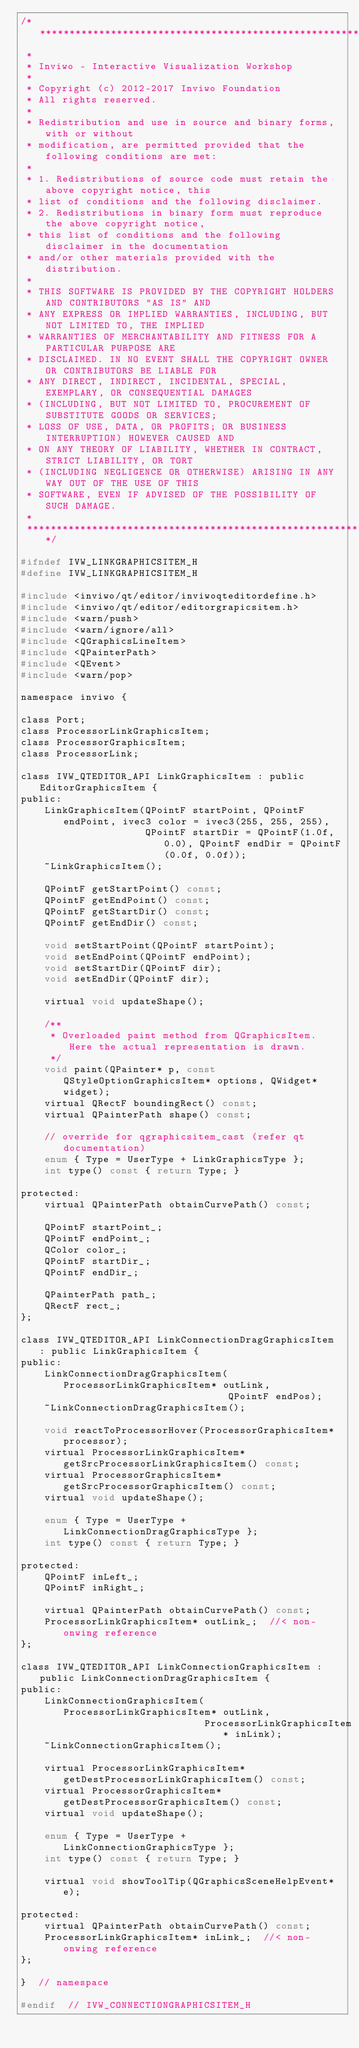<code> <loc_0><loc_0><loc_500><loc_500><_C_>/*********************************************************************************
 *
 * Inviwo - Interactive Visualization Workshop
 *
 * Copyright (c) 2012-2017 Inviwo Foundation
 * All rights reserved.
 *
 * Redistribution and use in source and binary forms, with or without
 * modification, are permitted provided that the following conditions are met:
 *
 * 1. Redistributions of source code must retain the above copyright notice, this
 * list of conditions and the following disclaimer.
 * 2. Redistributions in binary form must reproduce the above copyright notice,
 * this list of conditions and the following disclaimer in the documentation
 * and/or other materials provided with the distribution.
 *
 * THIS SOFTWARE IS PROVIDED BY THE COPYRIGHT HOLDERS AND CONTRIBUTORS "AS IS" AND
 * ANY EXPRESS OR IMPLIED WARRANTIES, INCLUDING, BUT NOT LIMITED TO, THE IMPLIED
 * WARRANTIES OF MERCHANTABILITY AND FITNESS FOR A PARTICULAR PURPOSE ARE
 * DISCLAIMED. IN NO EVENT SHALL THE COPYRIGHT OWNER OR CONTRIBUTORS BE LIABLE FOR
 * ANY DIRECT, INDIRECT, INCIDENTAL, SPECIAL, EXEMPLARY, OR CONSEQUENTIAL DAMAGES
 * (INCLUDING, BUT NOT LIMITED TO, PROCUREMENT OF SUBSTITUTE GOODS OR SERVICES;
 * LOSS OF USE, DATA, OR PROFITS; OR BUSINESS INTERRUPTION) HOWEVER CAUSED AND
 * ON ANY THEORY OF LIABILITY, WHETHER IN CONTRACT, STRICT LIABILITY, OR TORT
 * (INCLUDING NEGLIGENCE OR OTHERWISE) ARISING IN ANY WAY OUT OF THE USE OF THIS
 * SOFTWARE, EVEN IF ADVISED OF THE POSSIBILITY OF SUCH DAMAGE.
 * 
 *********************************************************************************/

#ifndef IVW_LINKGRAPHICSITEM_H
#define IVW_LINKGRAPHICSITEM_H

#include <inviwo/qt/editor/inviwoqteditordefine.h>
#include <inviwo/qt/editor/editorgrapicsitem.h>
#include <warn/push>
#include <warn/ignore/all>
#include <QGraphicsLineItem>
#include <QPainterPath>
#include <QEvent>
#include <warn/pop>

namespace inviwo {

class Port;
class ProcessorLinkGraphicsItem;
class ProcessorGraphicsItem;
class ProcessorLink;

class IVW_QTEDITOR_API LinkGraphicsItem : public EditorGraphicsItem {
public:
    LinkGraphicsItem(QPointF startPoint, QPointF endPoint, ivec3 color = ivec3(255, 255, 255),
                     QPointF startDir = QPointF(1.0f, 0.0), QPointF endDir = QPointF(0.0f, 0.0f));
    ~LinkGraphicsItem();

    QPointF getStartPoint() const;
    QPointF getEndPoint() const;
    QPointF getStartDir() const;
    QPointF getEndDir() const;

    void setStartPoint(QPointF startPoint);
    void setEndPoint(QPointF endPoint);
    void setStartDir(QPointF dir);
    void setEndDir(QPointF dir);

    virtual void updateShape();

    /**
     * Overloaded paint method from QGraphicsItem. Here the actual representation is drawn.
     */
    void paint(QPainter* p, const QStyleOptionGraphicsItem* options, QWidget* widget);
    virtual QRectF boundingRect() const;
    virtual QPainterPath shape() const;

    // override for qgraphicsitem_cast (refer qt documentation)
    enum { Type = UserType + LinkGraphicsType };
    int type() const { return Type; }

protected:
    virtual QPainterPath obtainCurvePath() const;

    QPointF startPoint_;
    QPointF endPoint_;
    QColor color_;
    QPointF startDir_;
    QPointF endDir_;

    QPainterPath path_;
    QRectF rect_;
};

class IVW_QTEDITOR_API LinkConnectionDragGraphicsItem : public LinkGraphicsItem {
public:
    LinkConnectionDragGraphicsItem(ProcessorLinkGraphicsItem* outLink,
                                   QPointF endPos);
    ~LinkConnectionDragGraphicsItem();

    void reactToProcessorHover(ProcessorGraphicsItem* processor);
    virtual ProcessorLinkGraphicsItem* getSrcProcessorLinkGraphicsItem() const;
    virtual ProcessorGraphicsItem* getSrcProcessorGraphicsItem() const;
    virtual void updateShape();

    enum { Type = UserType + LinkConnectionDragGraphicsType };
    int type() const { return Type; }

protected:
    QPointF inLeft_;
    QPointF inRight_;

    virtual QPainterPath obtainCurvePath() const;
    ProcessorLinkGraphicsItem* outLink_;  //< non-onwing reference
};

class IVW_QTEDITOR_API LinkConnectionGraphicsItem : public LinkConnectionDragGraphicsItem {
public:
    LinkConnectionGraphicsItem(ProcessorLinkGraphicsItem* outLink,
                               ProcessorLinkGraphicsItem* inLink);
    ~LinkConnectionGraphicsItem();

    virtual ProcessorLinkGraphicsItem* getDestProcessorLinkGraphicsItem() const;
    virtual ProcessorGraphicsItem* getDestProcessorGraphicsItem() const;
    virtual void updateShape();

    enum { Type = UserType + LinkConnectionGraphicsType };
    int type() const { return Type; }

    virtual void showToolTip(QGraphicsSceneHelpEvent* e);

protected:
    virtual QPainterPath obtainCurvePath() const;
    ProcessorLinkGraphicsItem* inLink_;  //< non-onwing reference
};

}  // namespace

#endif  // IVW_CONNECTIONGRAPHICSITEM_H</code> 